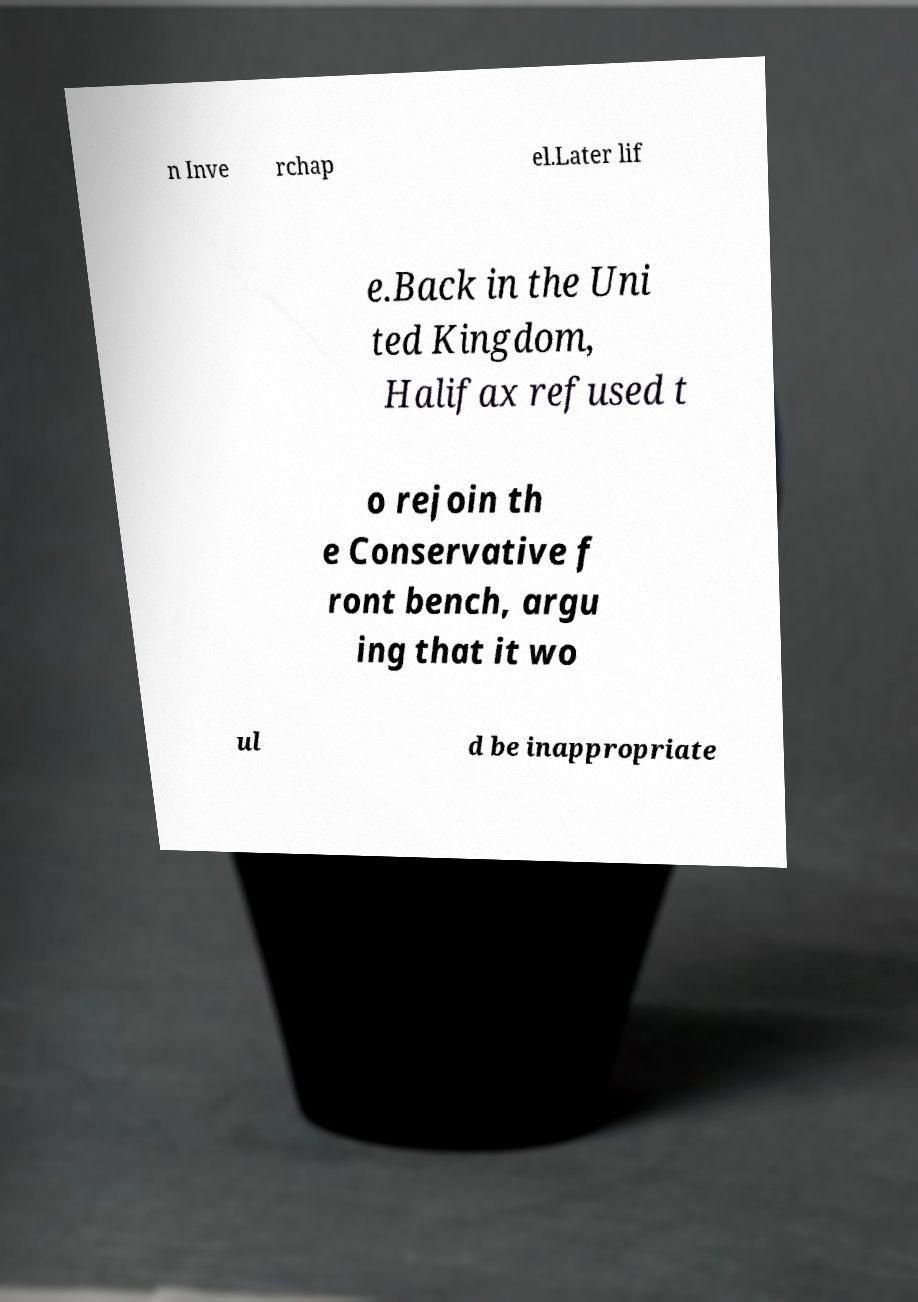Please read and relay the text visible in this image. What does it say? n Inve rchap el.Later lif e.Back in the Uni ted Kingdom, Halifax refused t o rejoin th e Conservative f ront bench, argu ing that it wo ul d be inappropriate 